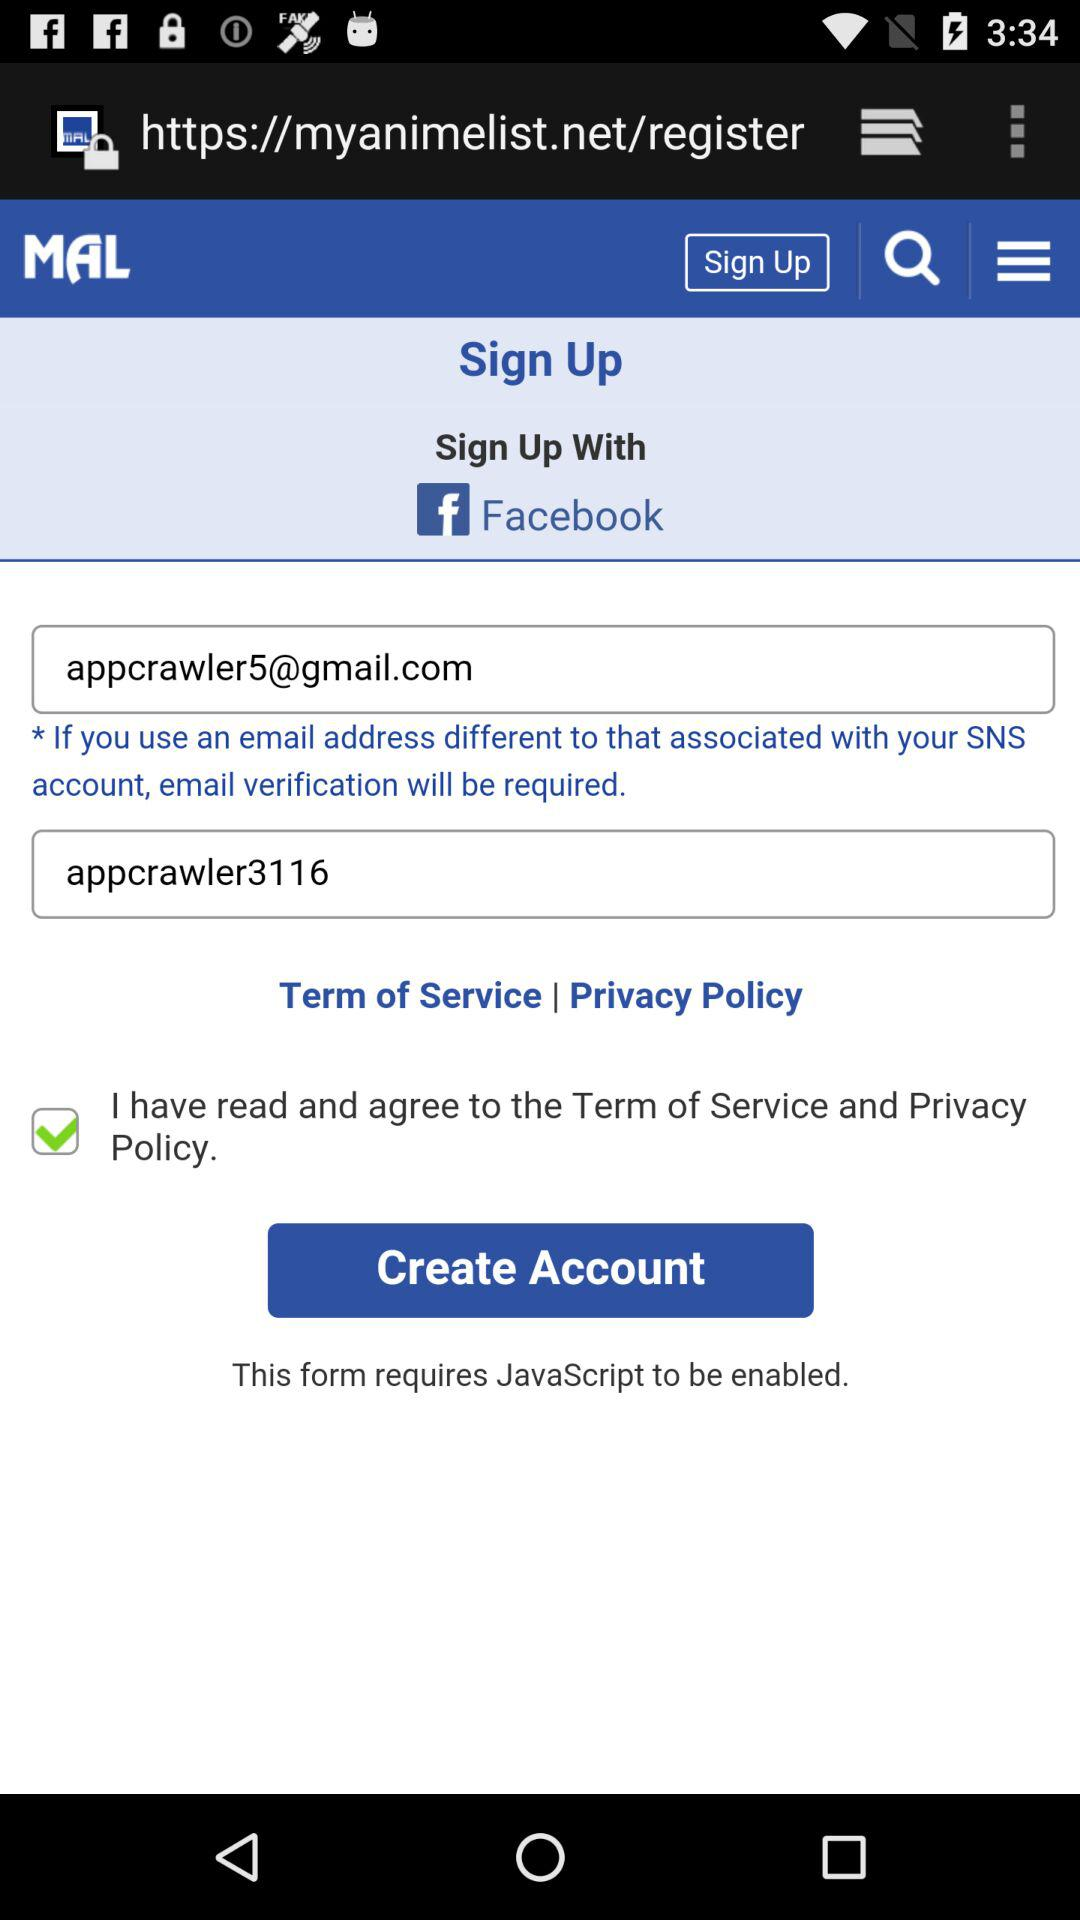What is the login email address? The login email address is appcrawler5@gmail.com. 